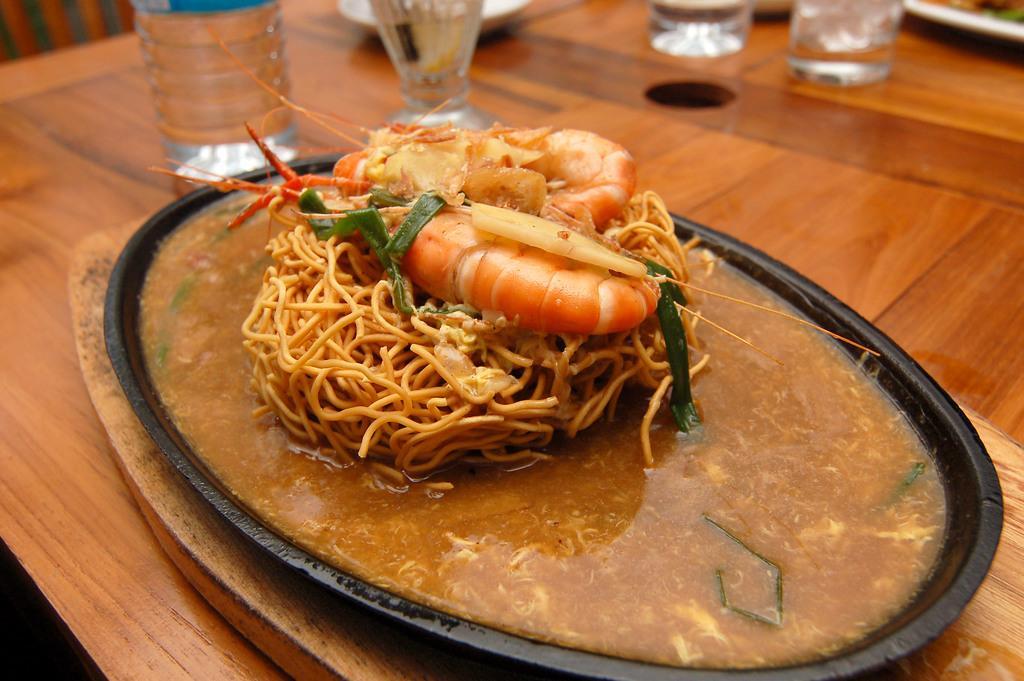Please provide a concise description of this image. In this image I can see a table and on it I can see a board, few glasses, a bottle, few plates and in these plates I can see different types of food. I can also see this image is little bit blurry. 